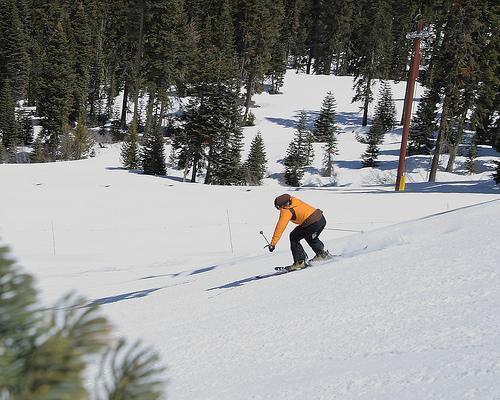How many people are there?
Give a very brief answer. 1. 